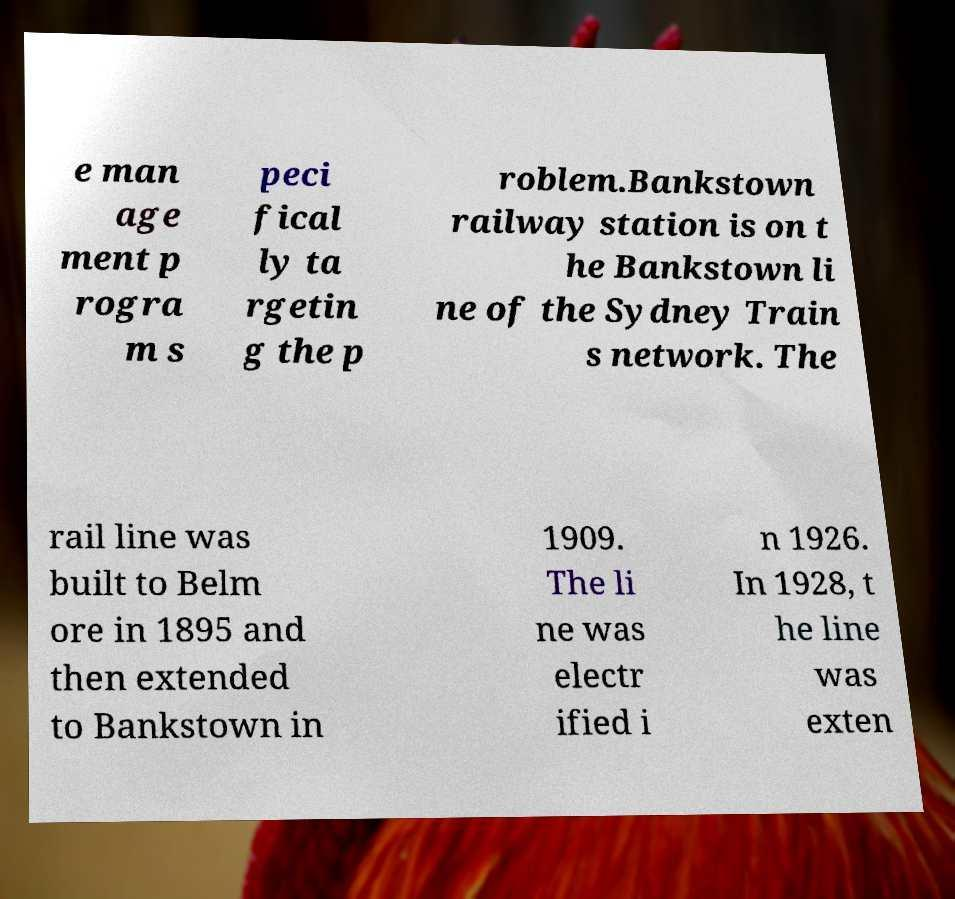What messages or text are displayed in this image? I need them in a readable, typed format. e man age ment p rogra m s peci fical ly ta rgetin g the p roblem.Bankstown railway station is on t he Bankstown li ne of the Sydney Train s network. The rail line was built to Belm ore in 1895 and then extended to Bankstown in 1909. The li ne was electr ified i n 1926. In 1928, t he line was exten 